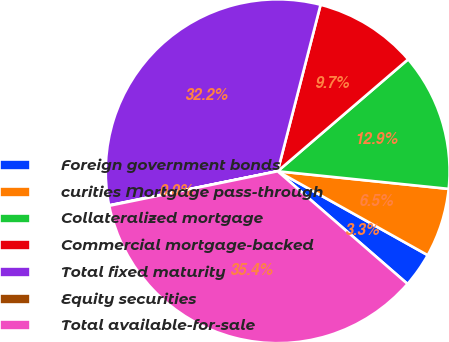Convert chart to OTSL. <chart><loc_0><loc_0><loc_500><loc_500><pie_chart><fcel>Foreign government bonds<fcel>curities Mortgage pass-through<fcel>Collateralized mortgage<fcel>Commercial mortgage-backed<fcel>Total fixed maturity<fcel>Equity securities<fcel>Total available-for-sale<nl><fcel>3.26%<fcel>6.48%<fcel>12.92%<fcel>9.7%<fcel>32.19%<fcel>0.04%<fcel>35.41%<nl></chart> 